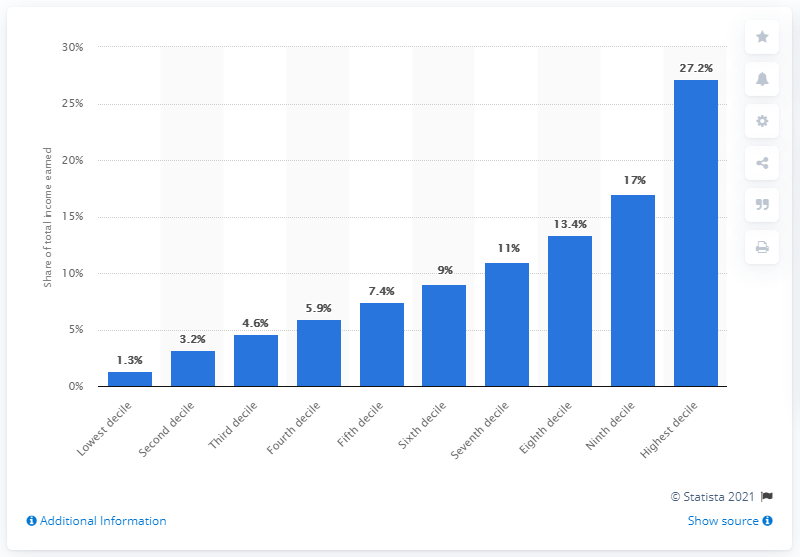Identify some key points in this picture. According to data from 2018, income earners in the top ten percent in Canada earned approximately 27.2 percent of their after-tax income. 